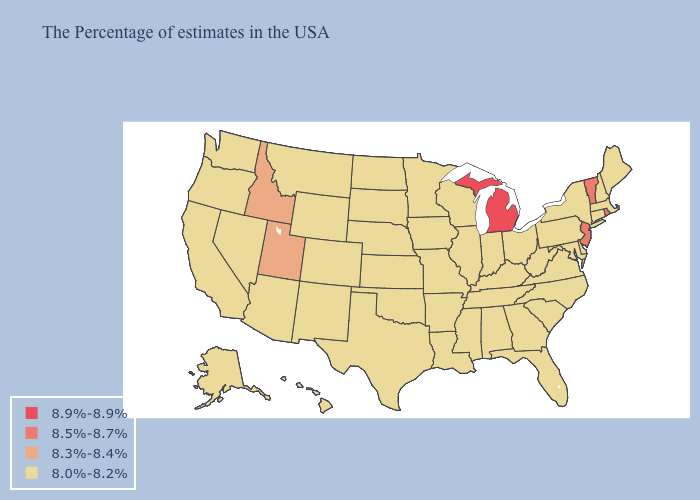What is the highest value in the Northeast ?
Answer briefly. 8.5%-8.7%. What is the highest value in states that border New York?
Keep it brief. 8.5%-8.7%. Does Wyoming have the highest value in the USA?
Write a very short answer. No. What is the value of Nevada?
Concise answer only. 8.0%-8.2%. What is the highest value in the USA?
Quick response, please. 8.9%-8.9%. Name the states that have a value in the range 8.5%-8.7%?
Quick response, please. Rhode Island, Vermont, New Jersey. What is the highest value in the USA?
Give a very brief answer. 8.9%-8.9%. Name the states that have a value in the range 8.9%-8.9%?
Concise answer only. Michigan. Does the first symbol in the legend represent the smallest category?
Write a very short answer. No. Name the states that have a value in the range 8.3%-8.4%?
Answer briefly. Utah, Idaho. How many symbols are there in the legend?
Answer briefly. 4. Which states have the lowest value in the Northeast?
Give a very brief answer. Maine, Massachusetts, New Hampshire, Connecticut, New York, Pennsylvania. Which states hav the highest value in the West?
Concise answer only. Utah, Idaho. What is the value of North Dakota?
Answer briefly. 8.0%-8.2%. 